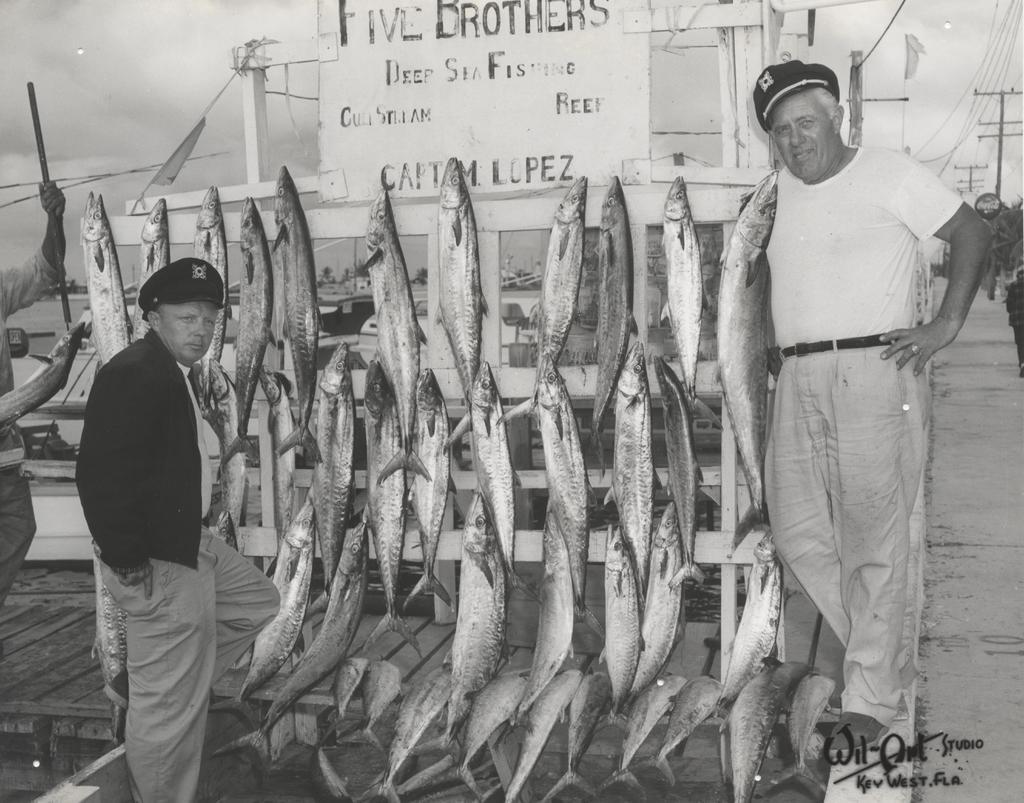Can you describe this image briefly? It is a black and white image,there are two men standing and posing for the photo and in between these two people there are lot of fishes hanged to a wooden background. 